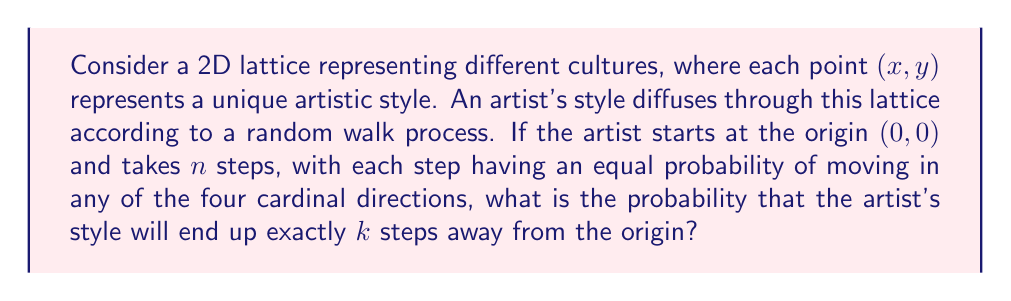Can you solve this math problem? To solve this problem, we'll follow these steps:

1) First, we need to understand that this is a 2D random walk problem. The artist's style can move up, down, left, or right with equal probability at each step.

2) The probability we're looking for is equivalent to the probability of the artist's style being at any point on a circle with radius $k$ after $n$ steps.

3) For the style to end up exactly $k$ steps away, the number of steps $n$ must be at least $k$, and $(n-k)$ must be even. This is because to reach a point $k$ steps away, the artist must take $k$ steps in the "correct" direction and the remaining steps must cancel out in pairs.

4) The probability is given by the formula:

   $$P(k,n) = \frac{4^k \binom{n}{\frac{n+k}{2}}}{4^n}$$

   Where $\binom{n}{\frac{n+k}{2}}$ is the binomial coefficient.

5) This formula can be derived as follows:
   - There are $4^n$ possible paths in total (4 choices for each of n steps).
   - There are $\binom{n}{\frac{n+k}{2}}$ ways to choose the $\frac{n+k}{2}$ steps that go in the "correct" direction.
   - For each of these choices, there are $4^k$ ways to arrange the $k$ "correct" steps among the 4 directions.

6) Therefore, the probability is the number of favorable outcomes divided by the total number of outcomes:

   $$P(k,n) = \frac{4^k \binom{n}{\frac{n+k}{2}}}{4^n}$$

7) Note that this formula is only valid when $n \geq k$ and $(n-k)$ is even. If these conditions are not met, the probability is 0.
Answer: $$P(k,n) = \frac{4^k \binom{n}{\frac{n+k}{2}}}{4^n}$$, where $n \geq k$ and $(n-k)$ is even 